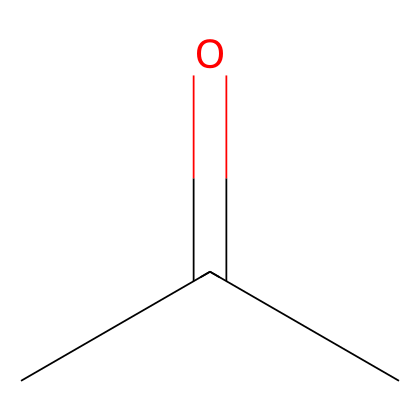What is the molecular formula of this compound? The molecular formula is derived from counting the number of each type of atom in the structure. The SMILES notation CC(=O)C indicates there are three carbon atoms (C), six hydrogen atoms (H), and one oxygen atom (O), leading to the formula C3H6O.
Answer: C3H6O How many total atoms are in acetone? To find the total number of atoms, add the individual counts: 3 carbon (C) atoms + 6 hydrogen (H) atoms + 1 oxygen (O) atom equals 10 atoms total.
Answer: 10 What is the functional group present in this chemical? In the provided SMILES, the structure has a carbonyl group (C=O) as indicated by the '=' bond, which is characteristic of ketones. Thus, the functional group is a ketone.
Answer: ketone Is acetone considered a flammable liquid? Acetone is known for its low flash point and high volatility, which makes it highly flammable. It readily ignites and burns easily, confirming its classification as a flammable liquid.
Answer: yes What type of bonding is primarily present in acetone? In acetone, there are multiple single (sigma) bonds between the carbon and hydrogen atoms, and a double bond (pi) between the carbon and oxygen in the carbonyl group. Thus, both single and double bonds are present, but the predominant type is sigma bonding.
Answer: sigma Which atom is the central atom that defines the reactivity of acetone? The central atom is the carbon atom in the carbonyl group (the carbon that is part of the C=O bond), as it plays a critical role in the reactivity of ketones, influencing their chemical behavior such as electrophilicity.
Answer: carbon 